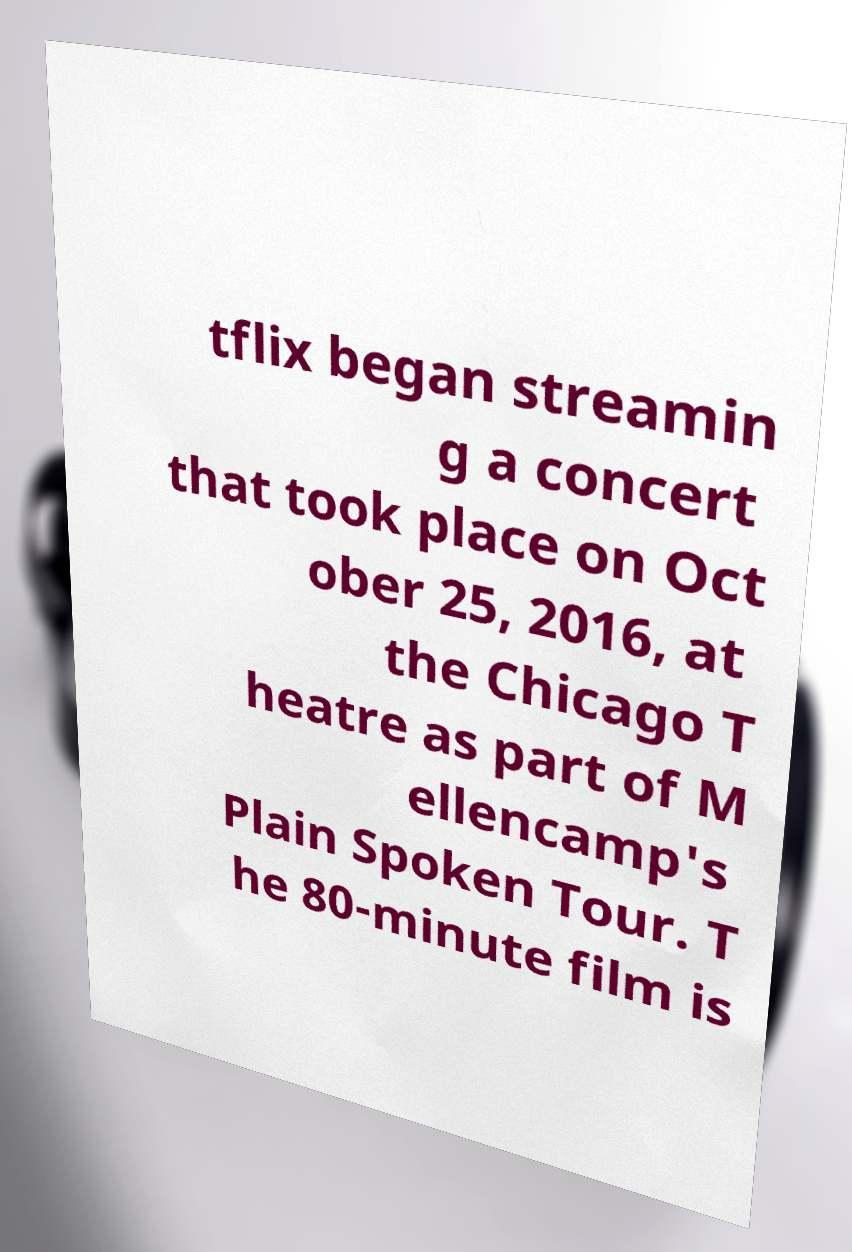What messages or text are displayed in this image? I need them in a readable, typed format. tflix began streamin g a concert that took place on Oct ober 25, 2016, at the Chicago T heatre as part of M ellencamp's Plain Spoken Tour. T he 80-minute film is 